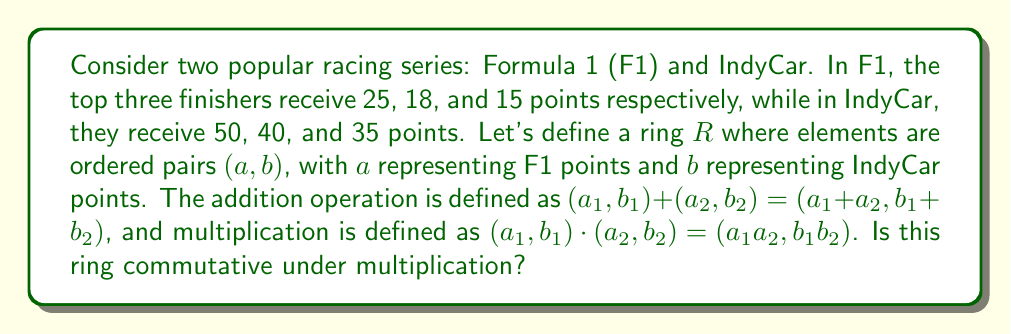Teach me how to tackle this problem. To determine if the ring $R$ is commutative under multiplication, we need to check if $x \cdot y = y \cdot x$ for all $x,y \in R$. Let's approach this step-by-step:

1) Let $x = (a_1,b_1)$ and $y = (a_2,b_2)$ be any two elements in $R$.

2) By the definition of multiplication in $R$:
   $x \cdot y = (a_1,b_1) \cdot (a_2,b_2) = (a_1a_2, b_1b_2)$
   $y \cdot x = (a_2,b_2) \cdot (a_1,b_1) = (a_2a_1, b_2b_1)$

3) For $R$ to be commutative, we need $(a_1a_2, b_1b_2) = (a_2a_1, b_2b_1)$ for all choices of $a_1, a_2, b_1, b_2$.

4) This equality holds if and only if:
   $a_1a_2 = a_2a_1$ and $b_1b_2 = b_2b_1$

5) We know that multiplication of real numbers is commutative. Since F1 and IndyCar points are real numbers, both $a_1a_2 = a_2a_1$ and $b_1b_2 = b_2b_1$ always hold.

6) Therefore, $(a_1a_2, b_1b_2) = (a_2a_1, b_2b_1)$ for all choices of $a_1, a_2, b_1, b_2$.

This means that $x \cdot y = y \cdot x$ for all $x,y \in R$, satisfying the definition of commutativity under multiplication.
Answer: Yes, the ring $R$ formed by race points awarded in F1 and IndyCar series is commutative under multiplication. 